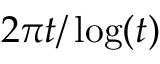Convert formula to latex. <formula><loc_0><loc_0><loc_500><loc_500>2 { \pi } t / \log ( t )</formula> 